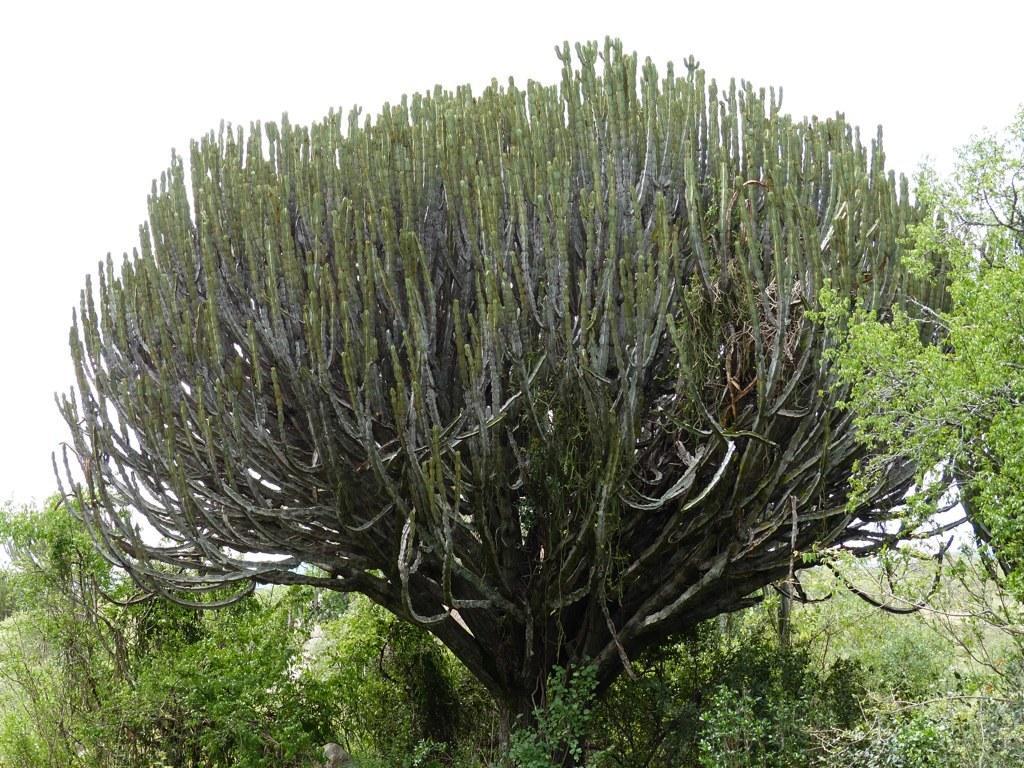Please provide a concise description of this image. There is greenery in the foreground area of the image and sky in the background area. 